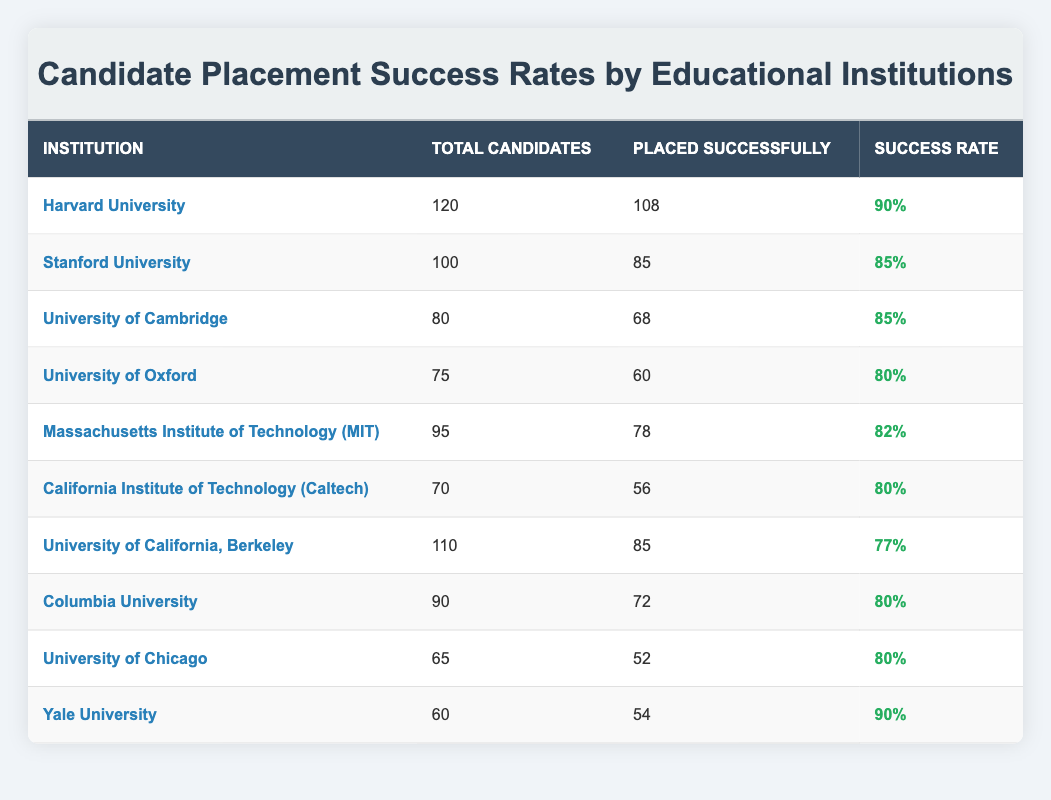What is the success rate of Harvard University? The success rate for Harvard University is displayed directly in the table. It reads 90%.
Answer: 90% How many candidates were placed successfully from Stanford University? The table shows that 85 candidates were placed successfully from Stanford University.
Answer: 85 Which institution had the highest success rate among the listed universities? Harvard University had the highest success rate at 90%, which can be compared to the other institutions in the table.
Answer: Harvard University What is the total number of candidates placed successfully from the University of California, Berkeley and Columbia University? The total placements can be calculated by adding the placements from each institution: 85 (UC Berkeley) + 72 (Columbia) = 157.
Answer: 157 Is the success rate of the University of Chicago higher than the University of Oxford? The University of Chicago has a success rate of 80%, while the University of Oxford also has a success rate of 80%. Therefore, they are equal, not higher.
Answer: No What is the average success rate of the institutions listed? To find the average, add all the success rates: (90 + 85 + 85 + 80 + 82 + 80 + 77 + 80 + 80 + 90) = 829. Divide by the number of institutions (10) to get the average success rate: 829 / 10 = 82.9.
Answer: 82.9 How many total candidates were there across all institutions listed? To find the total, sum the number of candidates from each institution shown in the table: 120 + 100 + 80 + 75 + 95 + 70 + 110 + 90 + 65 + 60 = 1000.
Answer: 1000 Did Yale University have a lower placement success rate than the Massachusetts Institute of Technology? Yale University had a success rate of 90% and MIT had 82%. Therefore, Yale's rate is higher than MIT's.
Answer: No Which institution placed the fewest number of candidates successfully? The University of Chicago placed 52 candidates successfully, which is the lowest number when comparing the data from all institutions in the table.
Answer: University of Chicago 